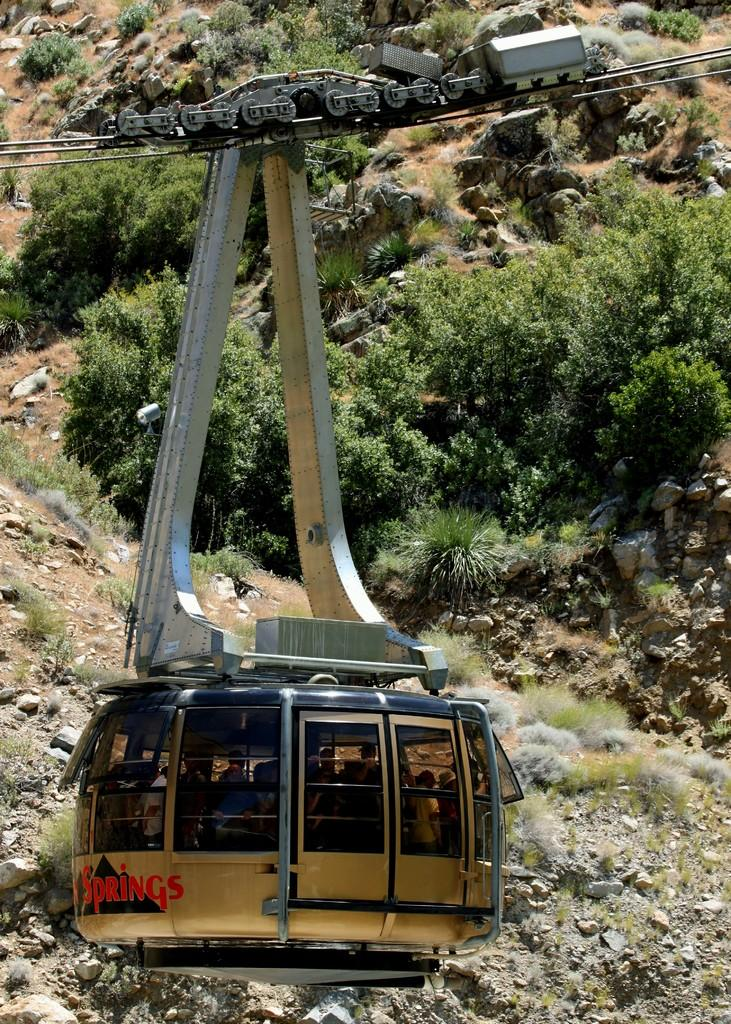What mode of transportation is featured in the image? There is a cable car in the image. What are the doors on the cable car used for? The doors on the cable car are used for entering and exiting the cable car. What material is used for the windows on the cable car? The windows on the cable car have glass. What type of terrain can be seen in the image? There is a slope visible in the image, which has rocks and plants. What word is written on the rocks in the image? There are no words written on the rocks in the image; they are natural formations with no text present. 